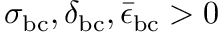Convert formula to latex. <formula><loc_0><loc_0><loc_500><loc_500>\sigma _ { b c } , \delta _ { b c } , \bar { \epsilon } _ { b c } > 0</formula> 